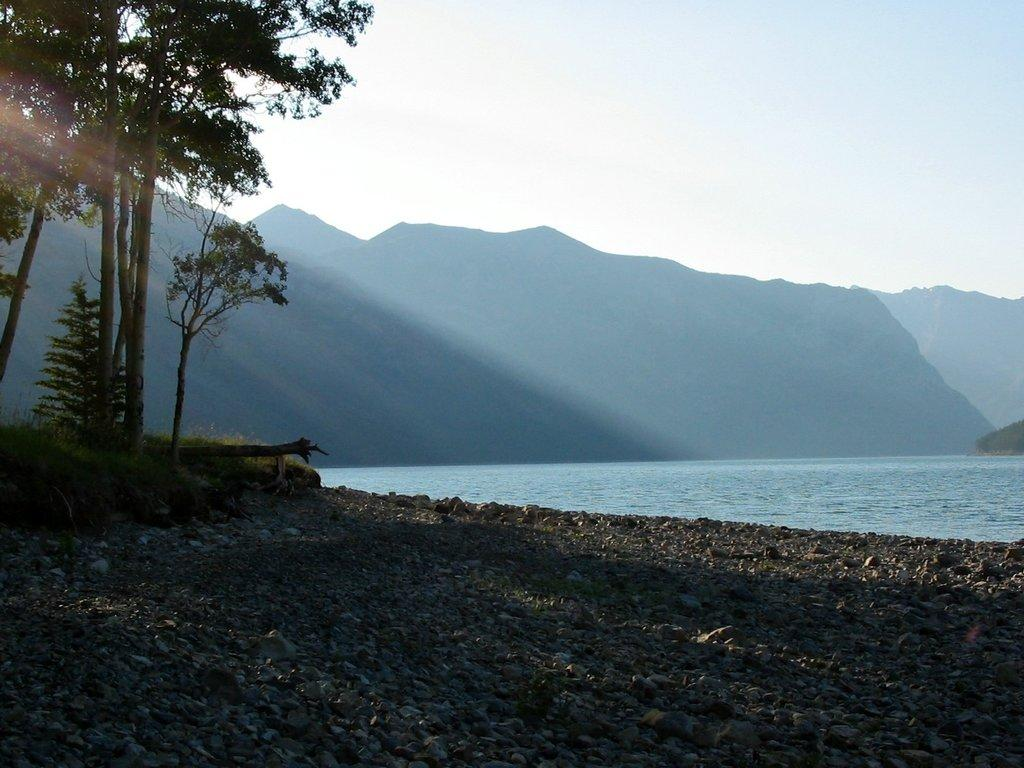What type of natural elements can be seen in the image? There are rocks, trees, plants, and water visible in the image. Where are the trees and plants located in the image? The trees and plants are in the left corner of the image. What can be seen in the background of the image? There are mountains in the background of the image. What type of leather is being used to construct the loaf in the image? There is no loaf or leather present in the image; it features natural elements such as rocks, trees, plants, water, and mountains. 